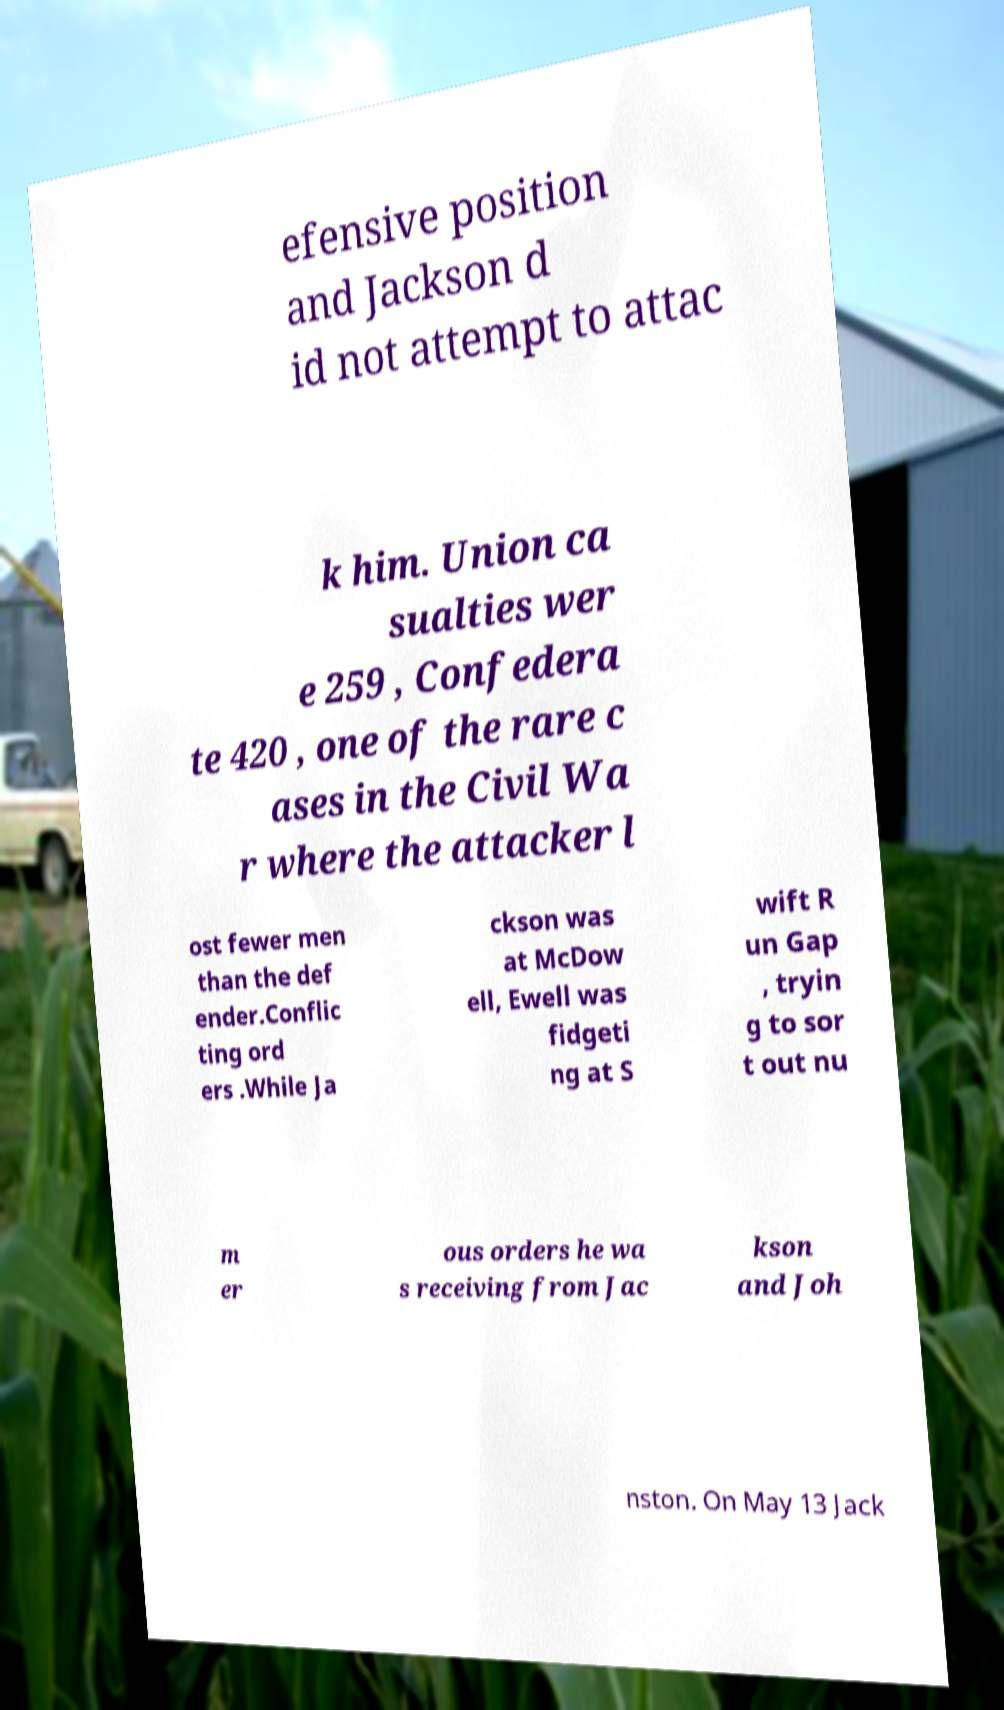There's text embedded in this image that I need extracted. Can you transcribe it verbatim? efensive position and Jackson d id not attempt to attac k him. Union ca sualties wer e 259 , Confedera te 420 , one of the rare c ases in the Civil Wa r where the attacker l ost fewer men than the def ender.Conflic ting ord ers .While Ja ckson was at McDow ell, Ewell was fidgeti ng at S wift R un Gap , tryin g to sor t out nu m er ous orders he wa s receiving from Jac kson and Joh nston. On May 13 Jack 